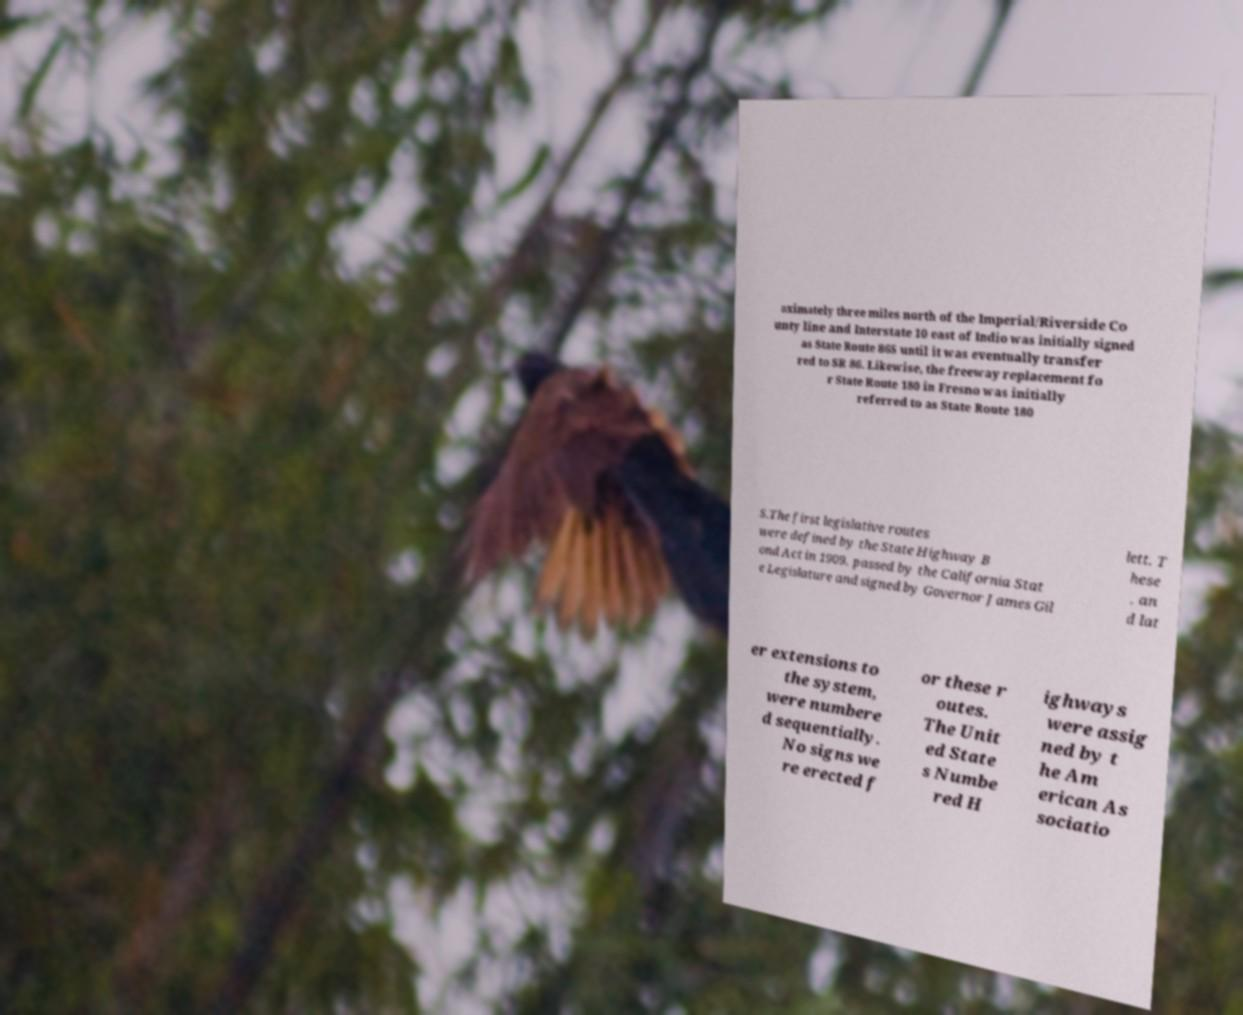For documentation purposes, I need the text within this image transcribed. Could you provide that? oximately three miles north of the Imperial/Riverside Co unty line and Interstate 10 east of Indio was initially signed as State Route 86S until it was eventually transfer red to SR 86. Likewise, the freeway replacement fo r State Route 180 in Fresno was initially referred to as State Route 180 S.The first legislative routes were defined by the State Highway B ond Act in 1909, passed by the California Stat e Legislature and signed by Governor James Gil lett. T hese , an d lat er extensions to the system, were numbere d sequentially. No signs we re erected f or these r outes. The Unit ed State s Numbe red H ighways were assig ned by t he Am erican As sociatio 